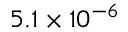<formula> <loc_0><loc_0><loc_500><loc_500>5 . 1 \times 1 0 ^ { - 6 }</formula> 